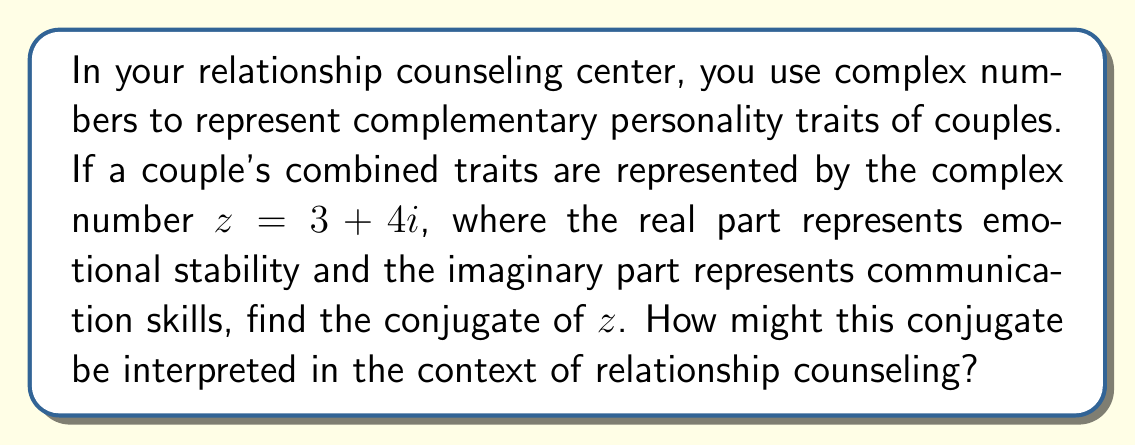Give your solution to this math problem. 1) The conjugate of a complex number $z = a + bi$ is defined as $\bar{z} = a - bi$.

2) In this case, $z = 3 + 4i$, so $a = 3$ and $b = 4$.

3) Applying the conjugate formula:
   $\bar{z} = 3 - 4i$

4) Interpretation in relationship counseling:
   - The real part (3) remains unchanged, indicating that emotional stability is consistent.
   - The imaginary part changes from positive to negative (-4i), which could represent a need to focus on improving communication skills.
   - The conjugate might represent an alternative perspective or approach to the couple's dynamics, highlighting areas for potential growth or balance.

5) In counseling, this could suggest exploring ways to maintain emotional stability while addressing communication challenges, or considering how different communication styles might complement each other.
Answer: $\bar{z} = 3 - 4i$ 